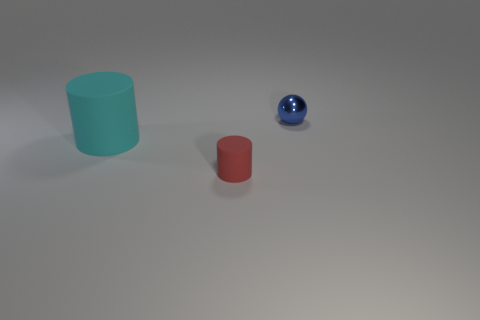Which objects have a reflective surface? The small blue sphere has a reflective surface, as indicated by the way it mirrors the environment on its glossy finish. 